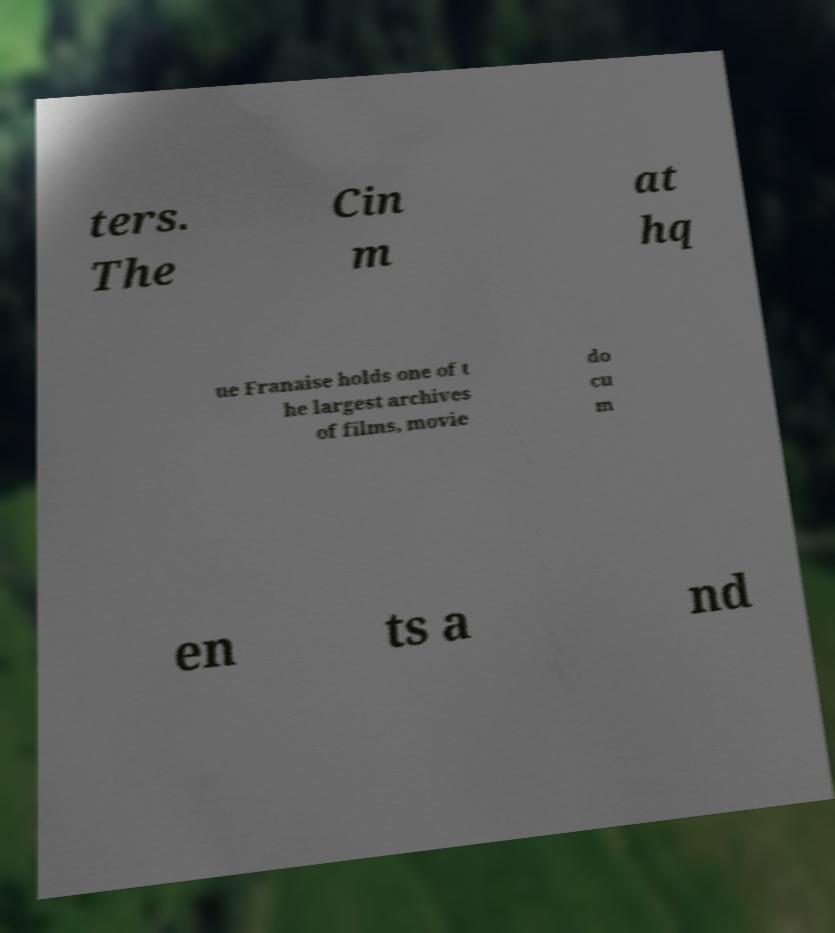For documentation purposes, I need the text within this image transcribed. Could you provide that? ters. The Cin m at hq ue Franaise holds one of t he largest archives of films, movie do cu m en ts a nd 